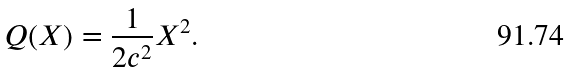Convert formula to latex. <formula><loc_0><loc_0><loc_500><loc_500>Q ( X ) = \frac { 1 } { 2 c ^ { 2 } } X ^ { 2 } .</formula> 